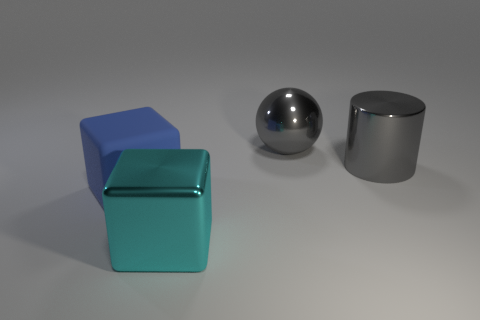Is there a rubber object that is in front of the cube that is behind the big object in front of the large blue rubber cube? After carefully observing the image, it appears that there is no rubber object located in front of the smaller cube that is behind the larger cylindrical object in front of the large blue cube. The objects present are a large blue cube, a smaller teal cube, a spherical object, and a cylindrical object. Materials are not discernible from the image alone. 